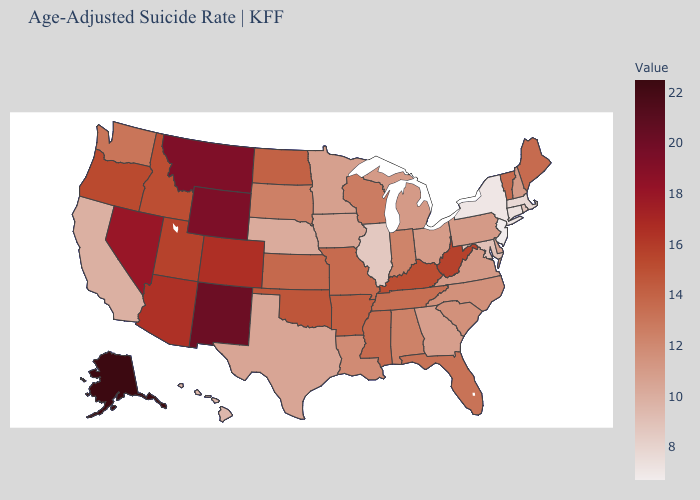Among the states that border Kentucky , does Illinois have the lowest value?
Give a very brief answer. Yes. 